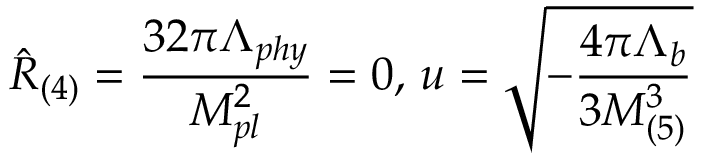Convert formula to latex. <formula><loc_0><loc_0><loc_500><loc_500>\hat { R } _ { ( 4 ) } = \frac { 3 2 \pi \Lambda _ { p h y } } { M _ { p l } ^ { 2 } } = 0 , \, u = \sqrt { - \frac { 4 \pi \Lambda _ { b } } { 3 M _ { ( 5 ) } ^ { 3 } } }</formula> 